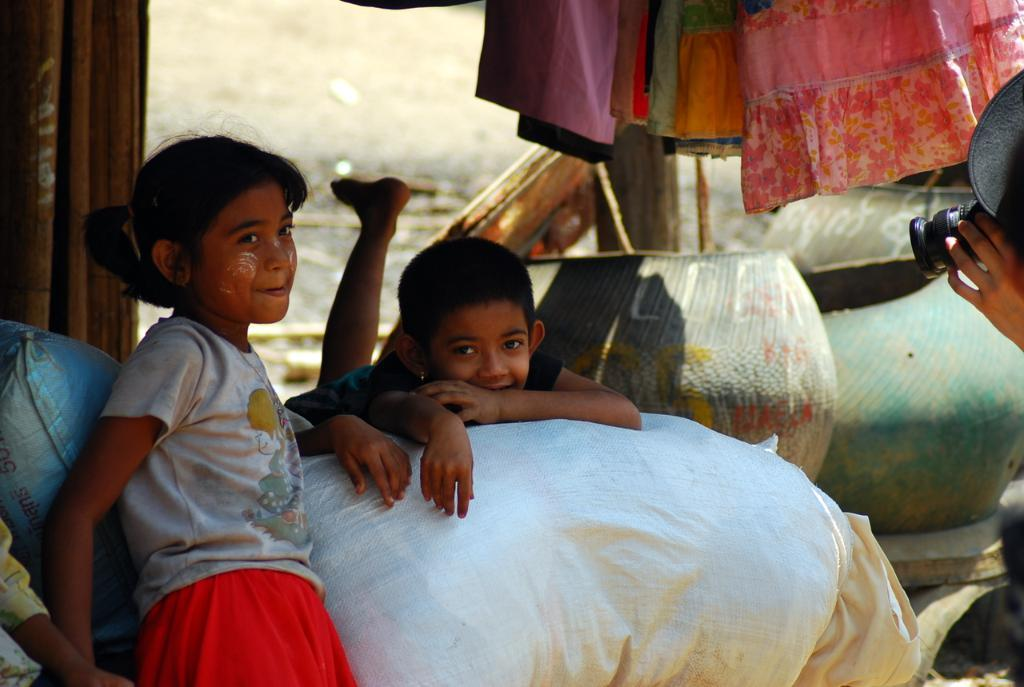What is happening in the image involving the people? There are people in the image, and one of them is capturing a photo with a camera. What is the position of the kid in the image? The kid is lying on the bed in the image. What can be seen in the background of the image? In the background of the image, there are curtains and pots. What type of grape is being used to copy the photo in the image? There is no grape present in the image, nor is there any copying of the photo being done. 